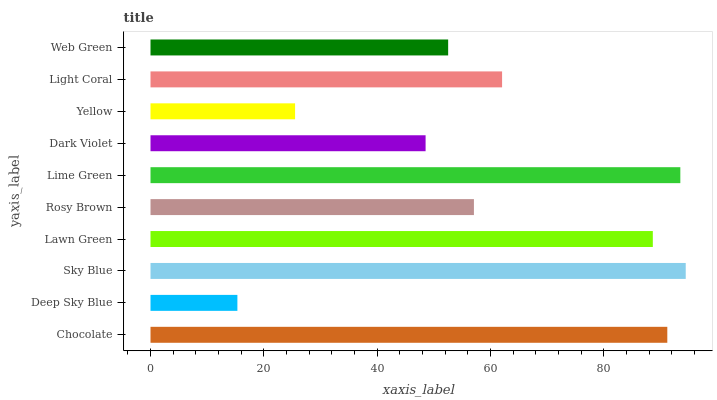Is Deep Sky Blue the minimum?
Answer yes or no. Yes. Is Sky Blue the maximum?
Answer yes or no. Yes. Is Sky Blue the minimum?
Answer yes or no. No. Is Deep Sky Blue the maximum?
Answer yes or no. No. Is Sky Blue greater than Deep Sky Blue?
Answer yes or no. Yes. Is Deep Sky Blue less than Sky Blue?
Answer yes or no. Yes. Is Deep Sky Blue greater than Sky Blue?
Answer yes or no. No. Is Sky Blue less than Deep Sky Blue?
Answer yes or no. No. Is Light Coral the high median?
Answer yes or no. Yes. Is Rosy Brown the low median?
Answer yes or no. Yes. Is Web Green the high median?
Answer yes or no. No. Is Light Coral the low median?
Answer yes or no. No. 